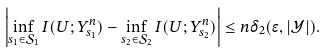<formula> <loc_0><loc_0><loc_500><loc_500>\left | \inf _ { s _ { 1 } \in \mathcal { S } _ { 1 } } I ( U ; Y ^ { n } _ { s _ { 1 } } ) - \inf _ { s _ { 2 } \in \mathcal { S } _ { 2 } } I ( U ; Y ^ { n } _ { s _ { 2 } } ) \right | \leq n \delta _ { 2 } ( \epsilon , | \mathcal { Y } | ) .</formula> 